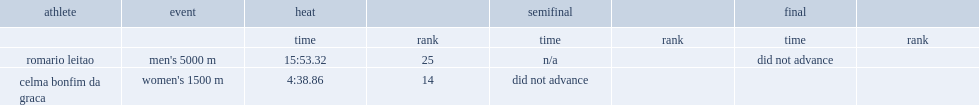What was leitao 's rank in the men's 5000 meters. 25.0. 